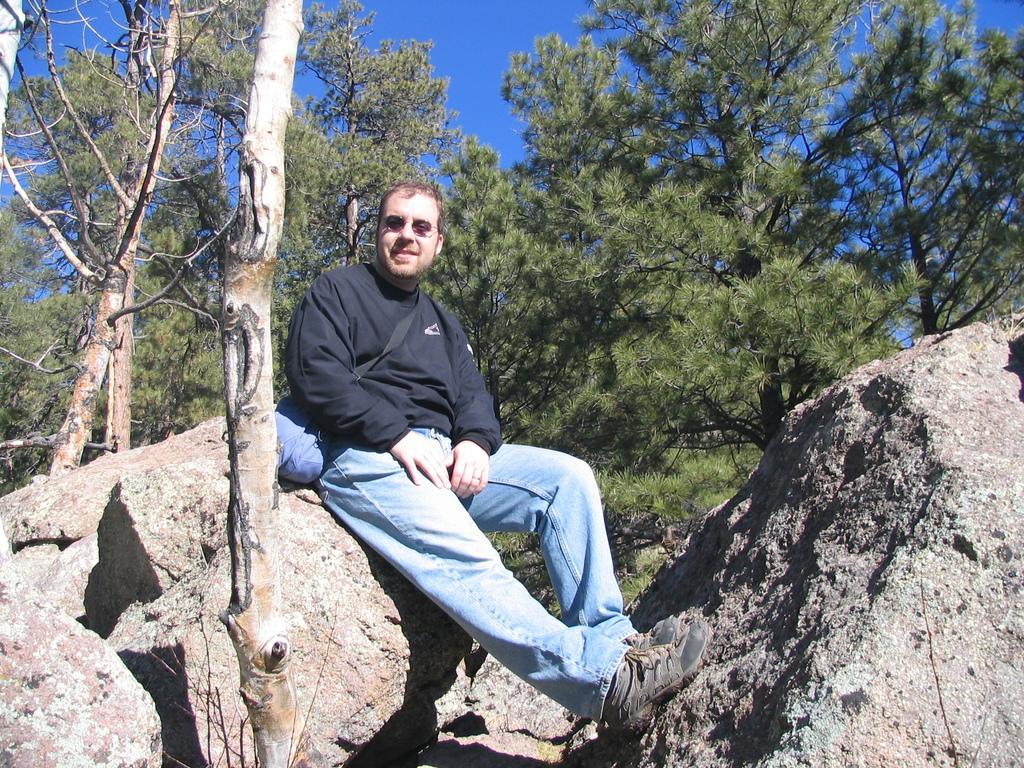How would you summarize this image in a sentence or two? This picture is taken from outside of the city and it is sunny. In this image, in the middle, we can see a man wearing a black color shirt and a backpack is sitting on the rocks. On the left side, we can see a wood pole. In the background, we can see some trees. At the top, we can see a sky, at the bottom, we can see some rocks on the land. 